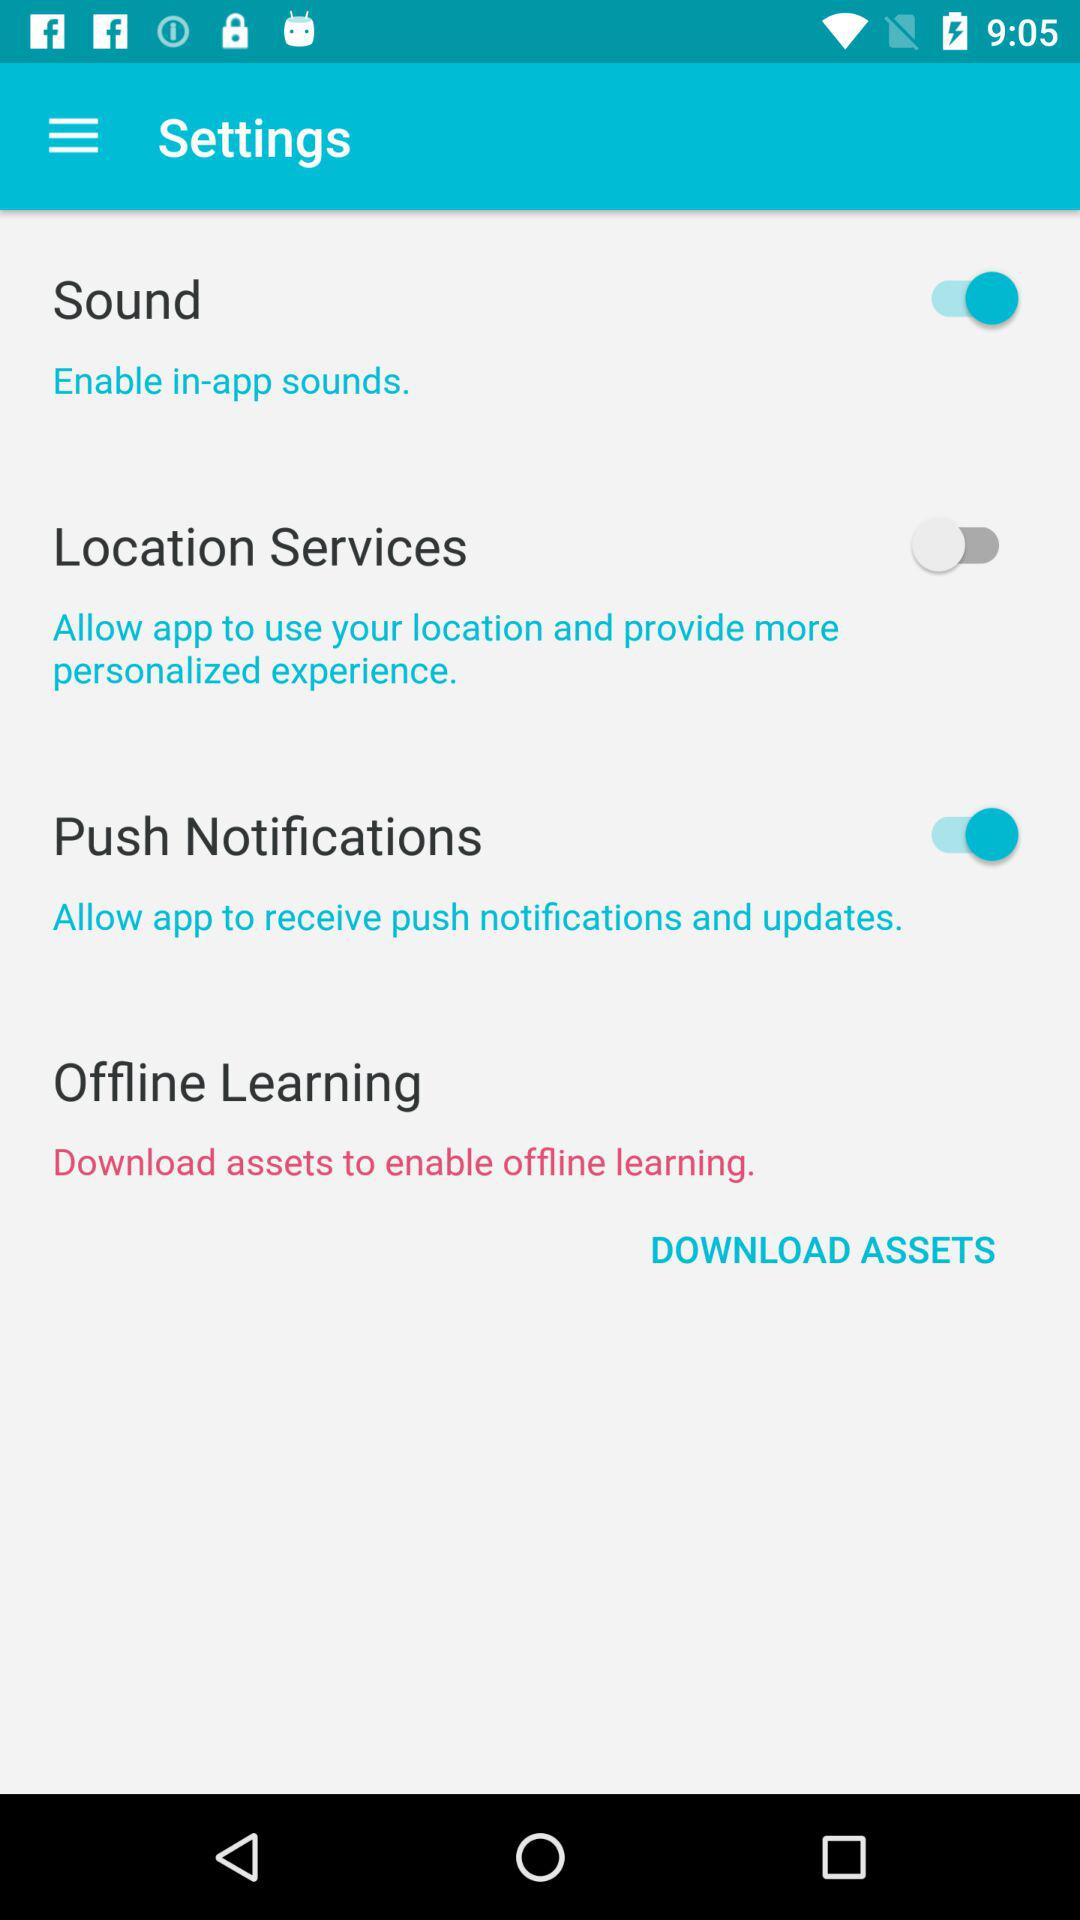How many toggles are there in this settings screen?
Answer the question using a single word or phrase. 3 